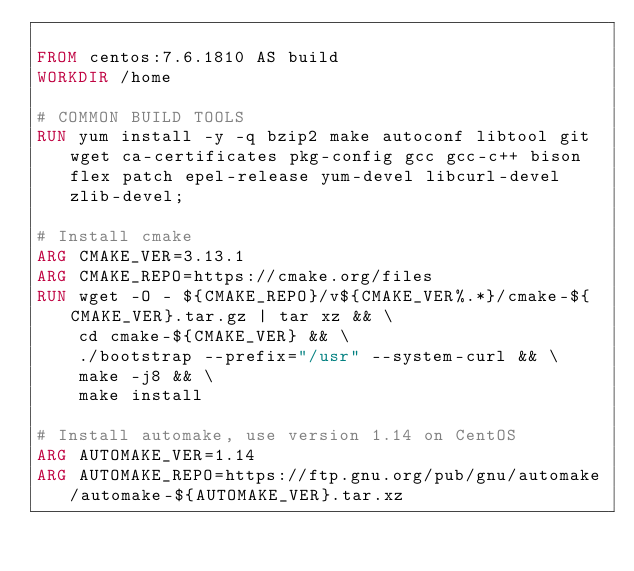<code> <loc_0><loc_0><loc_500><loc_500><_Dockerfile_>
FROM centos:7.6.1810 AS build
WORKDIR /home

# COMMON BUILD TOOLS
RUN yum install -y -q bzip2 make autoconf libtool git wget ca-certificates pkg-config gcc gcc-c++ bison flex patch epel-release yum-devel libcurl-devel zlib-devel;

# Install cmake
ARG CMAKE_VER=3.13.1
ARG CMAKE_REPO=https://cmake.org/files
RUN wget -O - ${CMAKE_REPO}/v${CMAKE_VER%.*}/cmake-${CMAKE_VER}.tar.gz | tar xz && \
    cd cmake-${CMAKE_VER} && \
    ./bootstrap --prefix="/usr" --system-curl && \
    make -j8 && \
    make install

# Install automake, use version 1.14 on CentOS
ARG AUTOMAKE_VER=1.14
ARG AUTOMAKE_REPO=https://ftp.gnu.org/pub/gnu/automake/automake-${AUTOMAKE_VER}.tar.xz</code> 